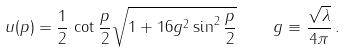<formula> <loc_0><loc_0><loc_500><loc_500>u ( p ) = \frac { 1 } { 2 } \, \cot \frac { p } { 2 } \sqrt { 1 + 1 6 g ^ { 2 } \sin ^ { 2 } \frac { p } { 2 } } \quad g \equiv \frac { \sqrt { \lambda } } { 4 \pi } \, .</formula> 